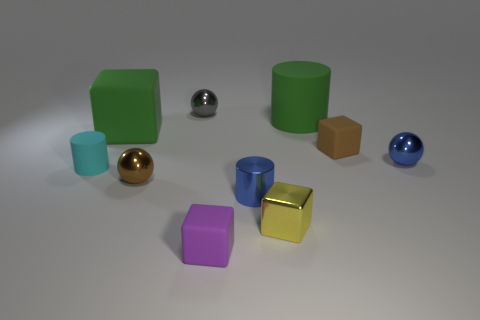Subtract all blocks. How many objects are left? 6 Subtract all small gray metal spheres. Subtract all tiny objects. How many objects are left? 1 Add 7 large rubber cylinders. How many large rubber cylinders are left? 8 Add 3 shiny balls. How many shiny balls exist? 6 Subtract 0 purple cylinders. How many objects are left? 10 